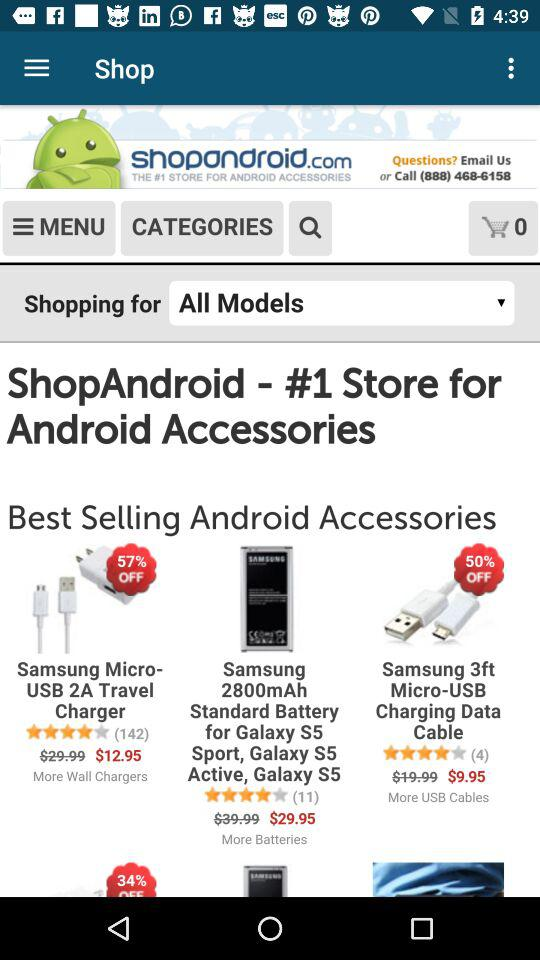How many people gave reviews for "Samsung Micro-USB 2A Travel Charger"? The number of people who gave reviews for "Samsung Micro-USB 2A Travel Charger" is 142. 